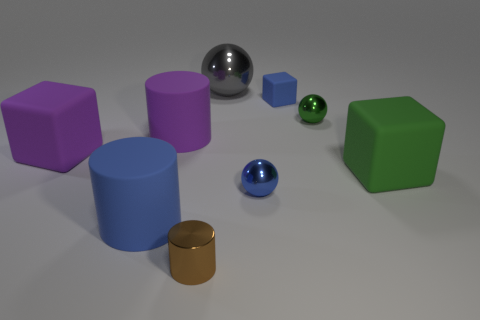Add 1 blue rubber cylinders. How many objects exist? 10 Subtract all blocks. How many objects are left? 6 Subtract all big yellow cylinders. Subtract all large green rubber blocks. How many objects are left? 8 Add 2 gray things. How many gray things are left? 3 Add 6 tiny blue spheres. How many tiny blue spheres exist? 7 Subtract 0 purple balls. How many objects are left? 9 